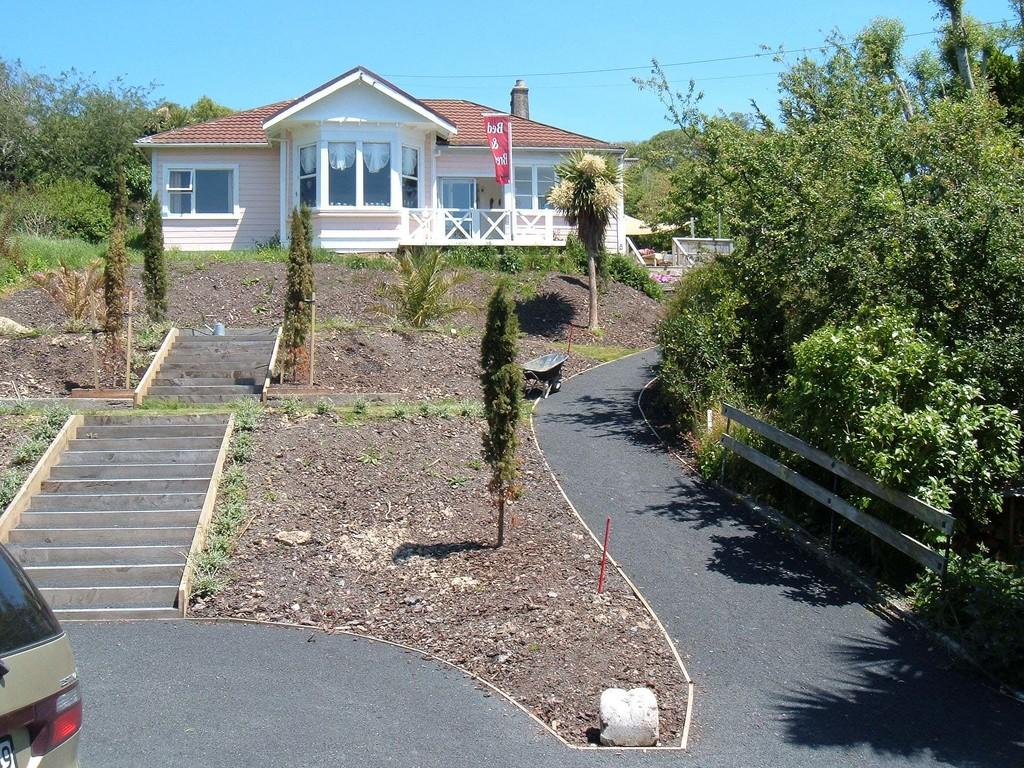What type of structure is visible in the image? There is a home in the image. What can be seen on either side of the home? Trees and plants are present on either side of the home. How can one access the home? There are steps in front of the home. What is visible beyond the steps? A road is visible after the steps. Is there any vehicle on the road? Yes, there is a car on the road. What type of peace symbol can be seen on the roof of the home? There is no peace symbol visible on the roof of the home in the image. 